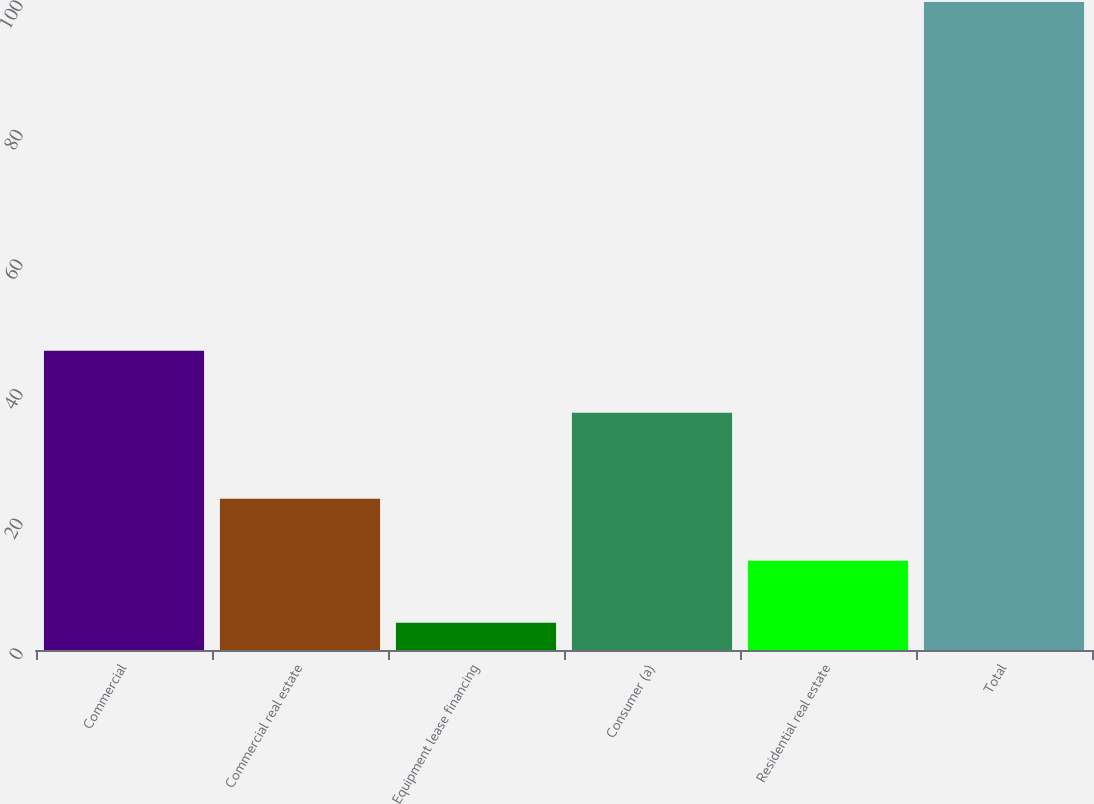Convert chart. <chart><loc_0><loc_0><loc_500><loc_500><bar_chart><fcel>Commercial<fcel>Commercial real estate<fcel>Equipment lease financing<fcel>Consumer (a)<fcel>Residential real estate<fcel>Total<nl><fcel>46.18<fcel>23.36<fcel>4.2<fcel>36.6<fcel>13.78<fcel>100<nl></chart> 